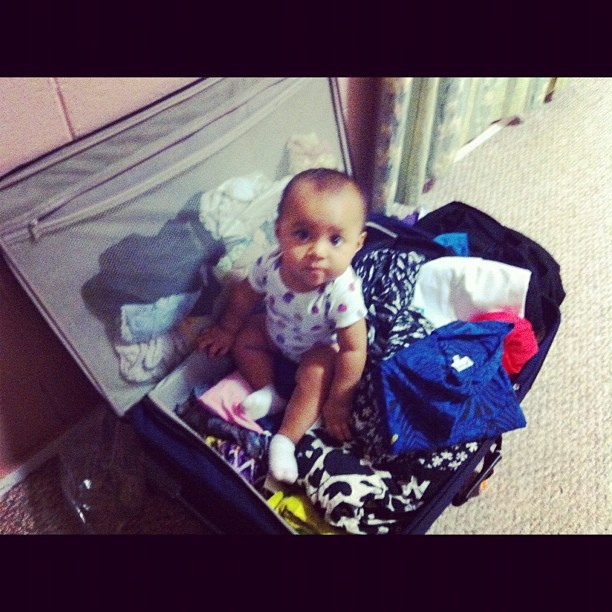Describe the objects in this image and their specific colors. I can see suitcase in black, darkgray, navy, and gray tones and people in black, purple, brown, and navy tones in this image. 